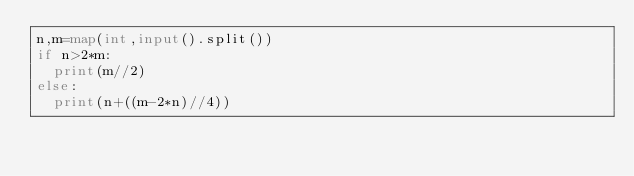<code> <loc_0><loc_0><loc_500><loc_500><_Python_>n,m=map(int,input().split())
if n>2*m:
  print(m//2)
else:
  print(n+((m-2*n)//4))</code> 